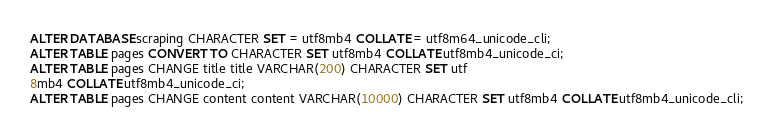Convert code to text. <code><loc_0><loc_0><loc_500><loc_500><_SQL_>ALTER DATABASE scraping CHARACTER SET = utf8mb4 COLLATE = utf8m64_unicode_cli;
ALTER TABLE pages CONVERT TO CHARACTER SET utf8mb4 COLLATE utf8mb4_unicode_ci;
ALTER TABLE pages CHANGE title title VARCHAR(200) CHARACTER SET utf
8mb4 COLLATE utf8mb4_unicode_ci;
ALTER TABLE pages CHANGE content content VARCHAR(10000) CHARACTER SET utf8mb4 COLLATE utf8mb4_unicode_cli;
</code> 